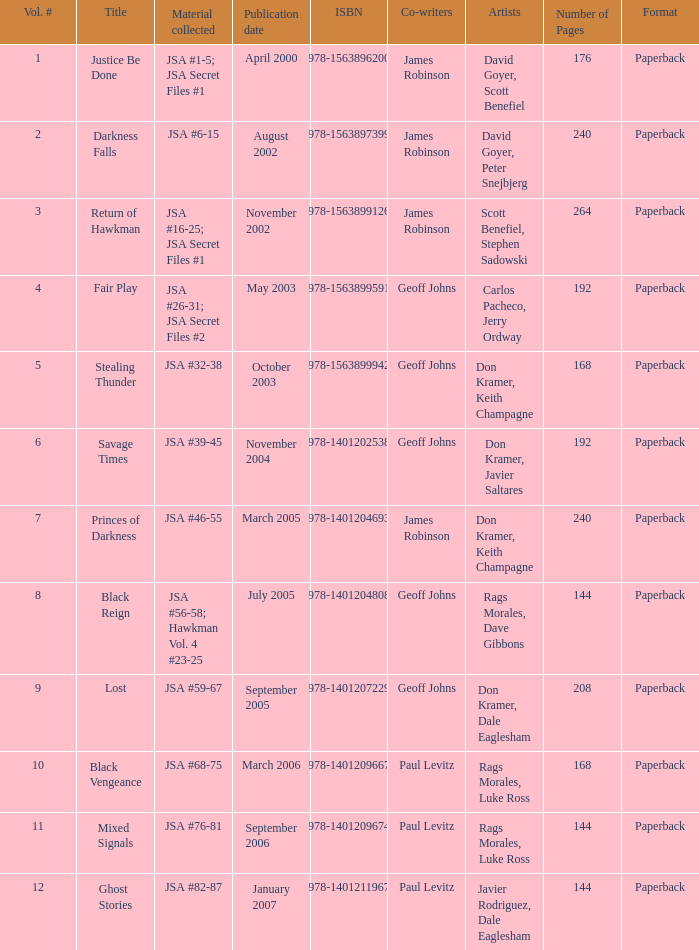How many Volume Numbers have the title of Darkness Falls? 2.0. 